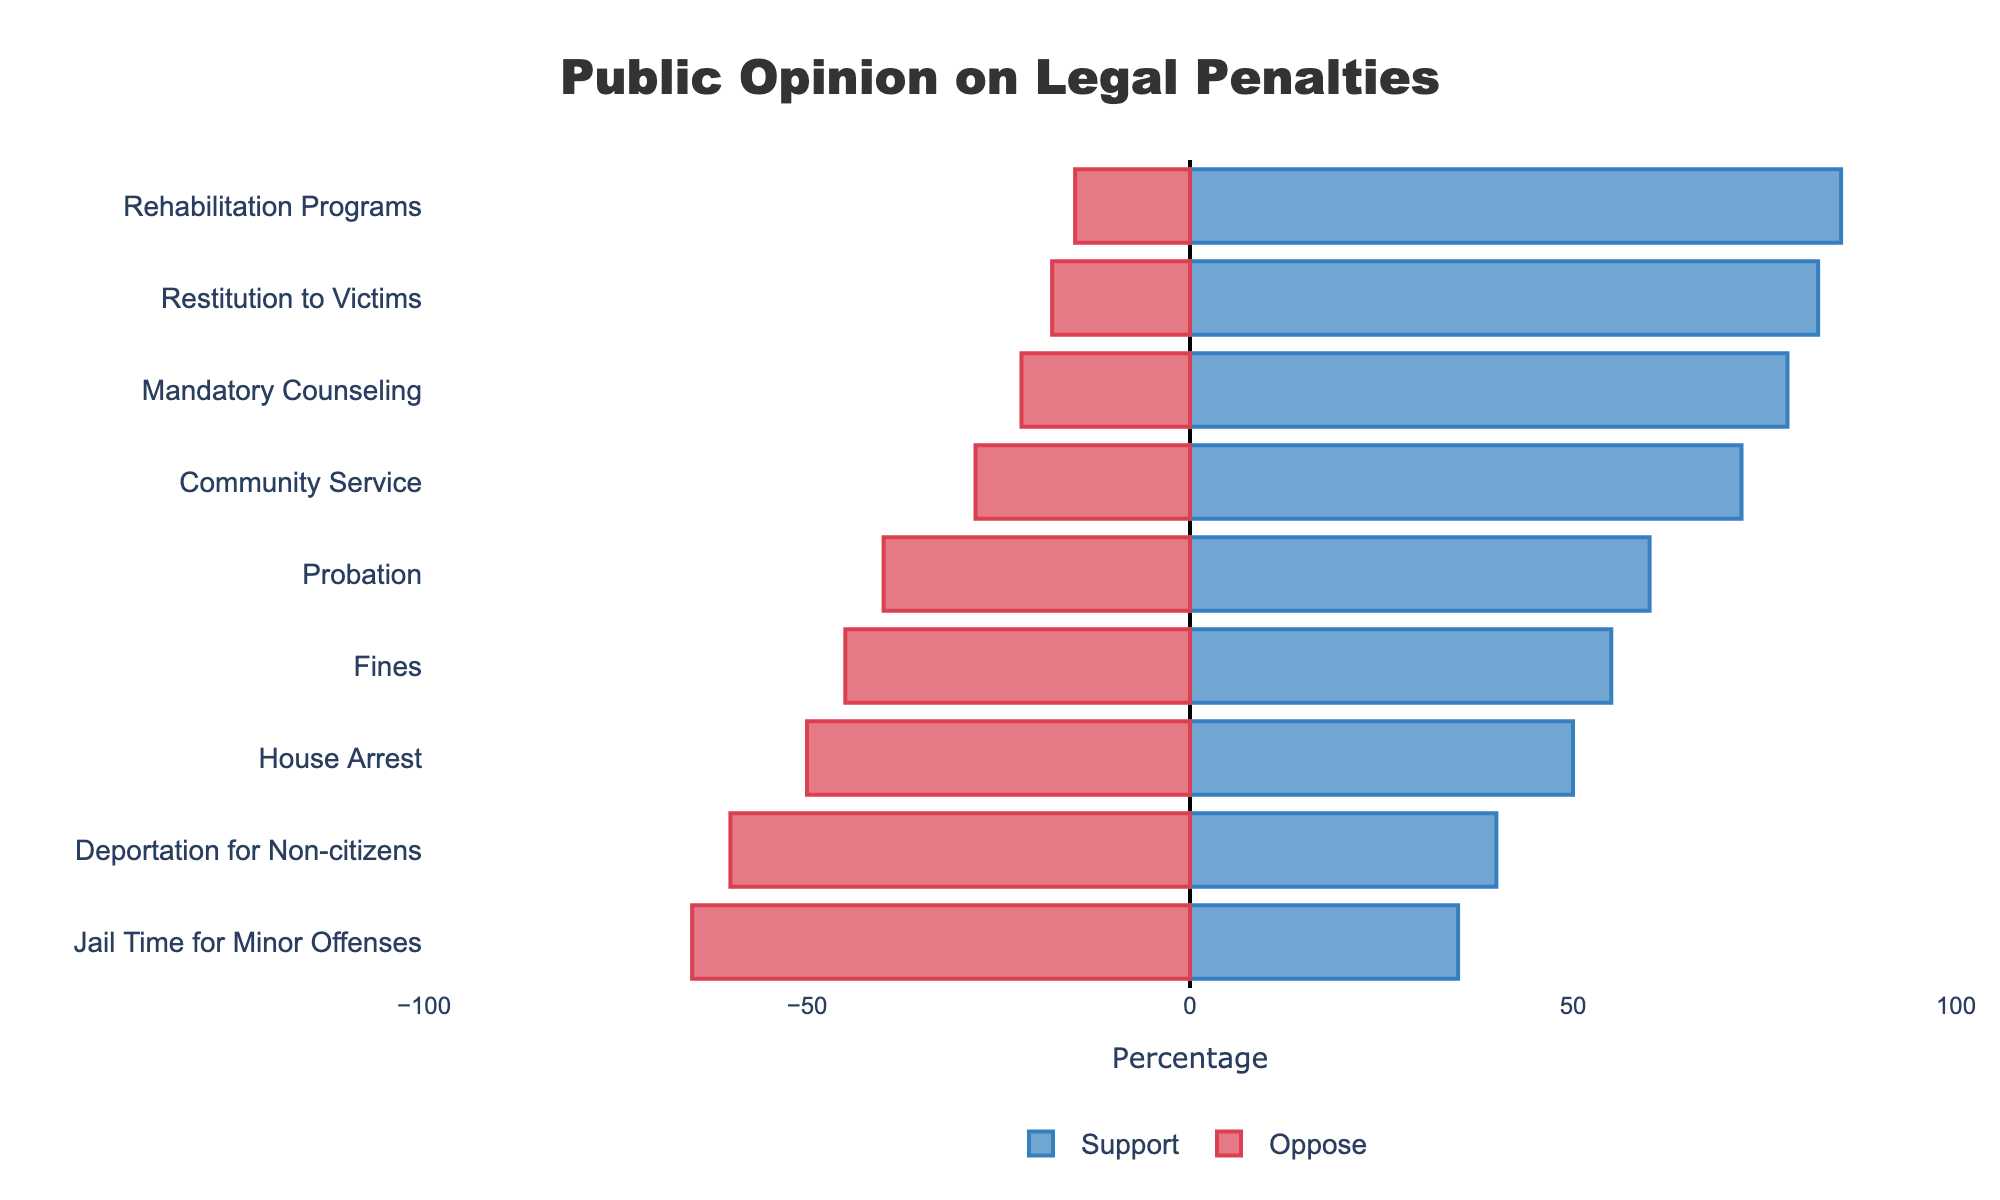What's the difference in public support between Rehabilitation Programs and Jail Time for Minor Offenses? To find the difference in public support, subtract the support percentage of Jail Time for Minor Offenses (35%) from that of Rehabilitation Programs (85%). 85% - 35% = 50%.
Answer: 50% Which legal penalty has the highest percentage of public opposition? Look at the bars representing opposition percentages. The longest bar represents Jail Time for Minor Offenses with 65%.
Answer: Jail Time for Minor Offenses Is Mandatory Counseling more supported or opposed by the public? Observe the length of the bars for Mandatory Counseling. The Support bar is longer at 78%, compared to the Oppose bar at 22%.
Answer: More supported What is the combined support percentage for Probation and Fines? Sum the support percentages of Probation (60%) and Fines (55%). 60% + 55% = 115%.
Answer: 115% Which categories have equal support and opposition, and what is the percentage? Look for bars whose Support and Oppose percentages are the same. House Arrest is the only category with equal support (50%) and opposition (50%).
Answer: House Arrest; 50% What is the average support for Community Service, Probation, and Restitution to Victims? Calculate the average support by summing their support percentages (72% for Community Service, 60% for Probation, and 82% for Restitution to Victims) and dividing by the number of categories (3). (72% + 60% + 82%) / 3 = 71.33%.
Answer: 71.33% Which legal penalty has the smallest difference between public support and opposition? The smallest difference is found by looking at the values closest to zero in the difference column. House Arrest has a difference of 0 (50% support - 50% oppose).
Answer: House Arrest Compare public support for Deportation for Non-citizens to Community Service. Which is greater and by how much? Compare the support percentages: Deportation for Non-citizens (40%) and Community Service (72%). Community Service is greater by 72% - 40% = 32%.
Answer: Community Service by 32% What proportion of the public opposes Probation? Look at the opposition percentage of Probation, which is 40%.
Answer: 40% What is the total percentage difference in support between Community Service and all forms combined? First, calculate the total percentage of all forms combined by summing their support percentages: 72% (Community Service) + 35% (Jail Time for Minor Offenses) + 60% (Probation) + 55% (Fines) + 50% (House Arrest) + 85% (Rehabilitation Programs) + 78% (Mandatory Counseling) + 82% (Restitution to Victims) + 40% (Deportation for Non-citizens) = 557%. Then divide by the number of forms (9) to get the average: 557% / 9 = 61.89%. Finally, subtract the average from Community Service's support: 72% - 61.89% = 10.11%.
Answer: 10.11% 